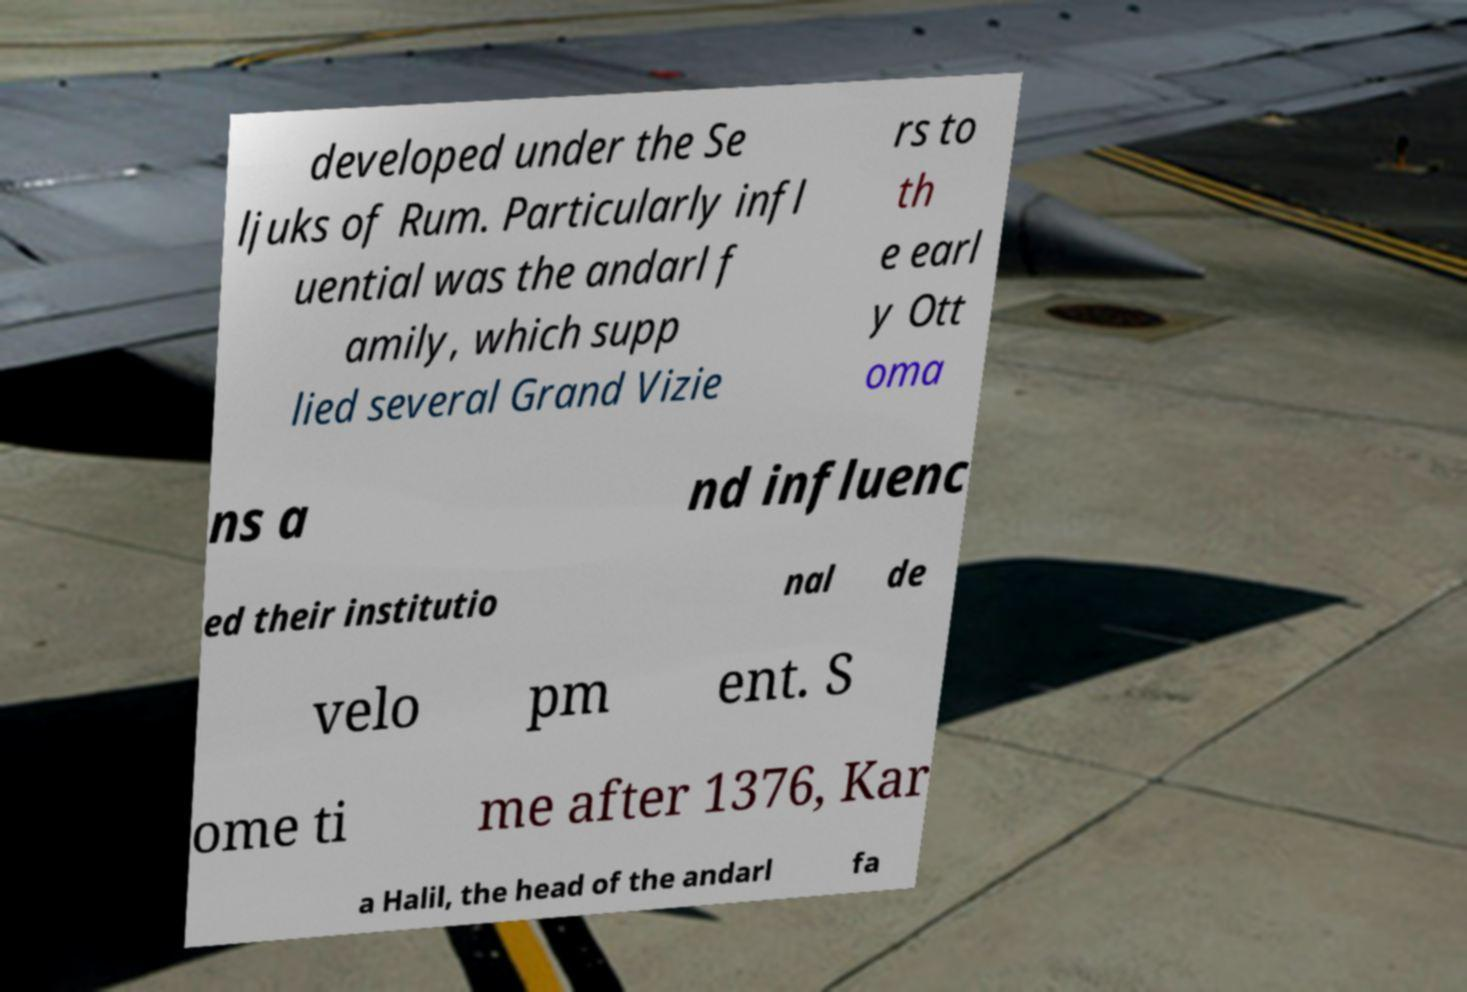Could you assist in decoding the text presented in this image and type it out clearly? developed under the Se ljuks of Rum. Particularly infl uential was the andarl f amily, which supp lied several Grand Vizie rs to th e earl y Ott oma ns a nd influenc ed their institutio nal de velo pm ent. S ome ti me after 1376, Kar a Halil, the head of the andarl fa 